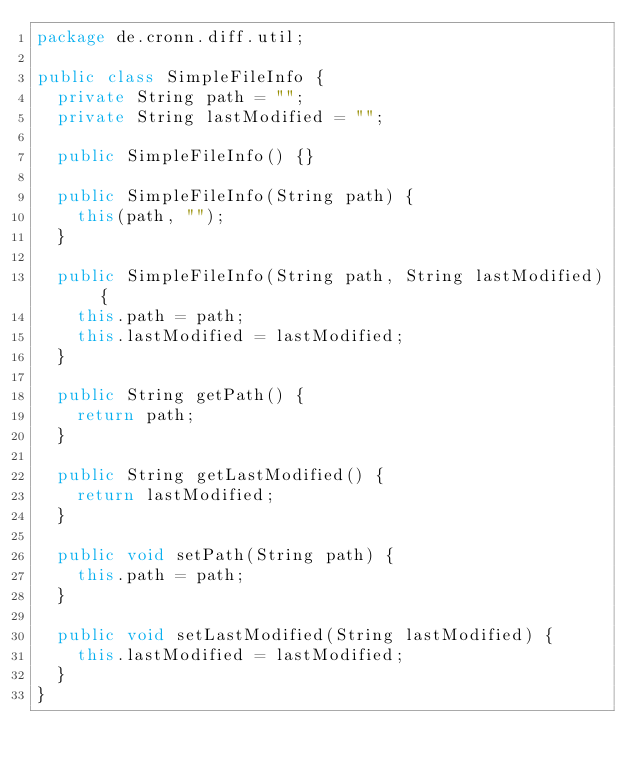Convert code to text. <code><loc_0><loc_0><loc_500><loc_500><_Java_>package de.cronn.diff.util;

public class SimpleFileInfo {
	private String path = "";
	private String lastModified = "";

	public SimpleFileInfo() {}

	public SimpleFileInfo(String path) {
		this(path, "");
	}

	public SimpleFileInfo(String path, String lastModified) {
		this.path = path;
		this.lastModified = lastModified;
	}

	public String getPath() {
		return path;
	}

	public String getLastModified() {
		return lastModified;
	}

	public void setPath(String path) {
		this.path = path;
	}

	public void setLastModified(String lastModified) {
		this.lastModified = lastModified;
	}
}</code> 